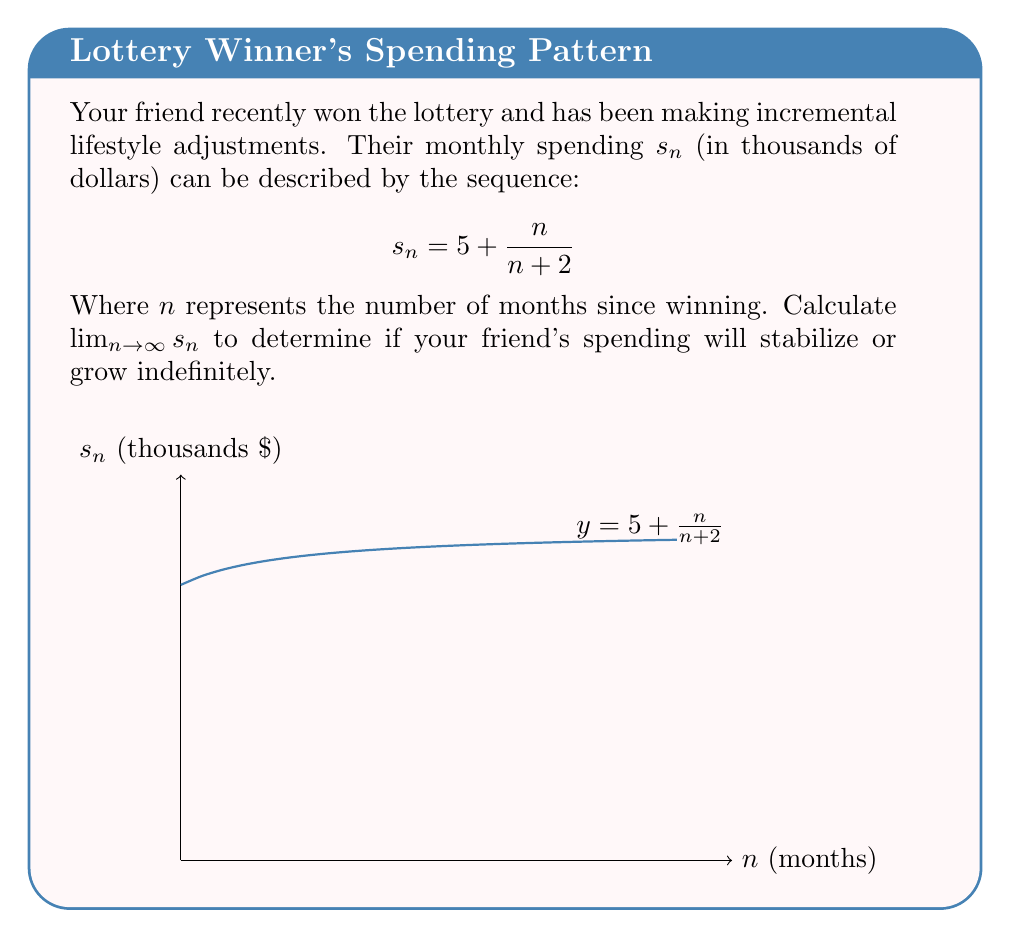What is the answer to this math problem? To find the limit of the sequence $s_n = 5 + \frac{n}{n+2}$ as $n$ approaches infinity, we can follow these steps:

1) First, let's analyze the fraction $\frac{n}{n+2}$:
   
   $$\lim_{n \to \infty} \frac{n}{n+2} = \lim_{n \to \infty} \frac{n/n}{(n+2)/n} = \lim_{n \to \infty} \frac{1}{1+2/n} = \frac{1}{1+0} = 1$$

2) Now, we can evaluate the limit of the entire sequence:

   $$\lim_{n \to \infty} s_n = \lim_{n \to \infty} (5 + \frac{n}{n+2})$$
   
   $$= 5 + \lim_{n \to \infty} \frac{n}{n+2}$$
   
   $$= 5 + 1 = 6$$

3) This result indicates that your friend's spending will stabilize at $6,000 per month as time goes on, rather than growing indefinitely.
Answer: $\lim_{n \to \infty} s_n = 6$ 